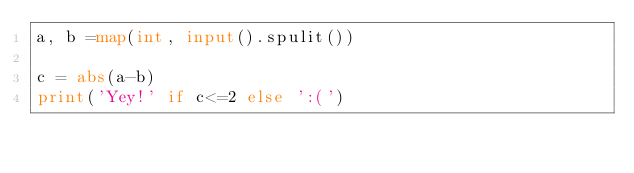Convert code to text. <code><loc_0><loc_0><loc_500><loc_500><_Python_>a, b =map(int, input().spulit())

c = abs(a-b)
print('Yey!' if c<=2 else ':(')</code> 